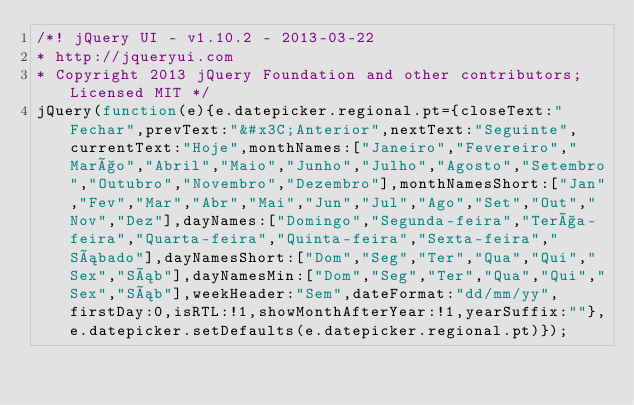Convert code to text. <code><loc_0><loc_0><loc_500><loc_500><_JavaScript_>/*! jQuery UI - v1.10.2 - 2013-03-22
* http://jqueryui.com
* Copyright 2013 jQuery Foundation and other contributors; Licensed MIT */
jQuery(function(e){e.datepicker.regional.pt={closeText:"Fechar",prevText:"&#x3C;Anterior",nextText:"Seguinte",currentText:"Hoje",monthNames:["Janeiro","Fevereiro","Março","Abril","Maio","Junho","Julho","Agosto","Setembro","Outubro","Novembro","Dezembro"],monthNamesShort:["Jan","Fev","Mar","Abr","Mai","Jun","Jul","Ago","Set","Out","Nov","Dez"],dayNames:["Domingo","Segunda-feira","Terça-feira","Quarta-feira","Quinta-feira","Sexta-feira","Sábado"],dayNamesShort:["Dom","Seg","Ter","Qua","Qui","Sex","Sáb"],dayNamesMin:["Dom","Seg","Ter","Qua","Qui","Sex","Sáb"],weekHeader:"Sem",dateFormat:"dd/mm/yy",firstDay:0,isRTL:!1,showMonthAfterYear:!1,yearSuffix:""},e.datepicker.setDefaults(e.datepicker.regional.pt)});</code> 